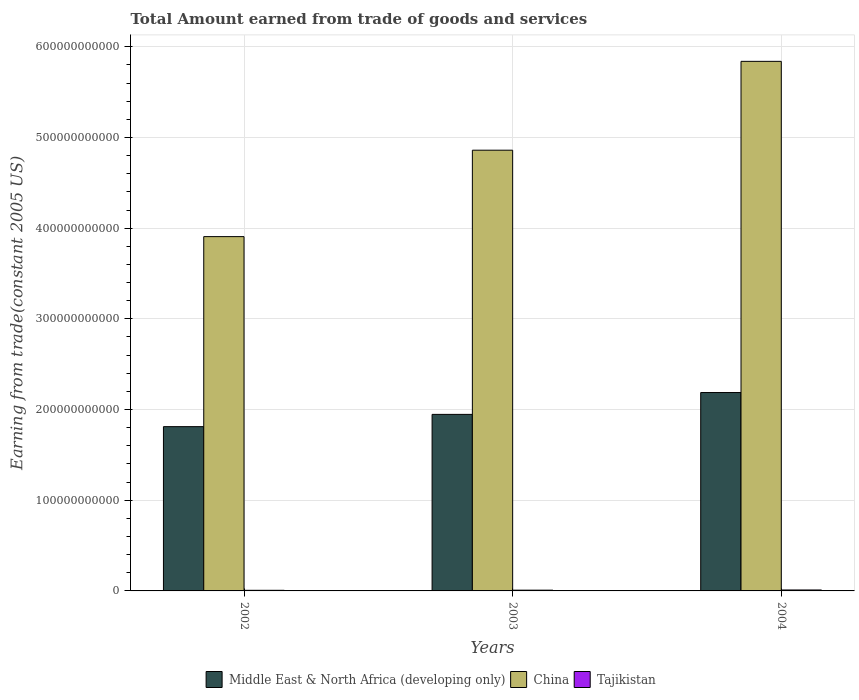How many different coloured bars are there?
Offer a very short reply. 3. Are the number of bars on each tick of the X-axis equal?
Your answer should be very brief. Yes. How many bars are there on the 1st tick from the left?
Your response must be concise. 3. How many bars are there on the 3rd tick from the right?
Your answer should be compact. 3. What is the total amount earned by trading goods and services in China in 2004?
Make the answer very short. 5.84e+11. Across all years, what is the maximum total amount earned by trading goods and services in Middle East & North Africa (developing only)?
Ensure brevity in your answer.  2.19e+11. Across all years, what is the minimum total amount earned by trading goods and services in Middle East & North Africa (developing only)?
Offer a terse response. 1.81e+11. In which year was the total amount earned by trading goods and services in China maximum?
Your answer should be compact. 2004. In which year was the total amount earned by trading goods and services in Middle East & North Africa (developing only) minimum?
Offer a very short reply. 2002. What is the total total amount earned by trading goods and services in Middle East & North Africa (developing only) in the graph?
Give a very brief answer. 5.95e+11. What is the difference between the total amount earned by trading goods and services in Middle East & North Africa (developing only) in 2002 and that in 2004?
Your answer should be compact. -3.76e+1. What is the difference between the total amount earned by trading goods and services in China in 2002 and the total amount earned by trading goods and services in Tajikistan in 2004?
Keep it short and to the point. 3.90e+11. What is the average total amount earned by trading goods and services in Tajikistan per year?
Your answer should be very brief. 8.51e+08. In the year 2002, what is the difference between the total amount earned by trading goods and services in Middle East & North Africa (developing only) and total amount earned by trading goods and services in Tajikistan?
Ensure brevity in your answer.  1.80e+11. What is the ratio of the total amount earned by trading goods and services in Tajikistan in 2002 to that in 2003?
Your response must be concise. 0.81. Is the total amount earned by trading goods and services in Middle East & North Africa (developing only) in 2002 less than that in 2003?
Keep it short and to the point. Yes. What is the difference between the highest and the second highest total amount earned by trading goods and services in Tajikistan?
Offer a terse response. 2.16e+08. What is the difference between the highest and the lowest total amount earned by trading goods and services in China?
Your answer should be very brief. 1.93e+11. In how many years, is the total amount earned by trading goods and services in Middle East & North Africa (developing only) greater than the average total amount earned by trading goods and services in Middle East & North Africa (developing only) taken over all years?
Provide a short and direct response. 1. What does the 2nd bar from the left in 2002 represents?
Offer a terse response. China. What does the 3rd bar from the right in 2003 represents?
Provide a succinct answer. Middle East & North Africa (developing only). What is the difference between two consecutive major ticks on the Y-axis?
Your answer should be compact. 1.00e+11. Are the values on the major ticks of Y-axis written in scientific E-notation?
Your answer should be compact. No. How are the legend labels stacked?
Offer a very short reply. Horizontal. What is the title of the graph?
Offer a terse response. Total Amount earned from trade of goods and services. Does "Pakistan" appear as one of the legend labels in the graph?
Your response must be concise. No. What is the label or title of the X-axis?
Your answer should be very brief. Years. What is the label or title of the Y-axis?
Your answer should be very brief. Earning from trade(constant 2005 US). What is the Earning from trade(constant 2005 US) of Middle East & North Africa (developing only) in 2002?
Make the answer very short. 1.81e+11. What is the Earning from trade(constant 2005 US) in China in 2002?
Your answer should be compact. 3.91e+11. What is the Earning from trade(constant 2005 US) in Tajikistan in 2002?
Provide a short and direct response. 6.73e+08. What is the Earning from trade(constant 2005 US) of Middle East & North Africa (developing only) in 2003?
Offer a terse response. 1.95e+11. What is the Earning from trade(constant 2005 US) of China in 2003?
Provide a short and direct response. 4.86e+11. What is the Earning from trade(constant 2005 US) in Tajikistan in 2003?
Give a very brief answer. 8.32e+08. What is the Earning from trade(constant 2005 US) of Middle East & North Africa (developing only) in 2004?
Provide a short and direct response. 2.19e+11. What is the Earning from trade(constant 2005 US) of China in 2004?
Your answer should be compact. 5.84e+11. What is the Earning from trade(constant 2005 US) of Tajikistan in 2004?
Keep it short and to the point. 1.05e+09. Across all years, what is the maximum Earning from trade(constant 2005 US) in Middle East & North Africa (developing only)?
Make the answer very short. 2.19e+11. Across all years, what is the maximum Earning from trade(constant 2005 US) in China?
Ensure brevity in your answer.  5.84e+11. Across all years, what is the maximum Earning from trade(constant 2005 US) in Tajikistan?
Give a very brief answer. 1.05e+09. Across all years, what is the minimum Earning from trade(constant 2005 US) of Middle East & North Africa (developing only)?
Provide a short and direct response. 1.81e+11. Across all years, what is the minimum Earning from trade(constant 2005 US) in China?
Make the answer very short. 3.91e+11. Across all years, what is the minimum Earning from trade(constant 2005 US) of Tajikistan?
Offer a terse response. 6.73e+08. What is the total Earning from trade(constant 2005 US) in Middle East & North Africa (developing only) in the graph?
Offer a terse response. 5.95e+11. What is the total Earning from trade(constant 2005 US) in China in the graph?
Keep it short and to the point. 1.46e+12. What is the total Earning from trade(constant 2005 US) of Tajikistan in the graph?
Keep it short and to the point. 2.55e+09. What is the difference between the Earning from trade(constant 2005 US) of Middle East & North Africa (developing only) in 2002 and that in 2003?
Offer a very short reply. -1.35e+1. What is the difference between the Earning from trade(constant 2005 US) of China in 2002 and that in 2003?
Keep it short and to the point. -9.53e+1. What is the difference between the Earning from trade(constant 2005 US) of Tajikistan in 2002 and that in 2003?
Provide a succinct answer. -1.59e+08. What is the difference between the Earning from trade(constant 2005 US) in Middle East & North Africa (developing only) in 2002 and that in 2004?
Offer a very short reply. -3.76e+1. What is the difference between the Earning from trade(constant 2005 US) of China in 2002 and that in 2004?
Make the answer very short. -1.93e+11. What is the difference between the Earning from trade(constant 2005 US) in Tajikistan in 2002 and that in 2004?
Offer a terse response. -3.75e+08. What is the difference between the Earning from trade(constant 2005 US) in Middle East & North Africa (developing only) in 2003 and that in 2004?
Provide a short and direct response. -2.41e+1. What is the difference between the Earning from trade(constant 2005 US) of China in 2003 and that in 2004?
Offer a terse response. -9.80e+1. What is the difference between the Earning from trade(constant 2005 US) of Tajikistan in 2003 and that in 2004?
Give a very brief answer. -2.16e+08. What is the difference between the Earning from trade(constant 2005 US) of Middle East & North Africa (developing only) in 2002 and the Earning from trade(constant 2005 US) of China in 2003?
Your answer should be very brief. -3.05e+11. What is the difference between the Earning from trade(constant 2005 US) of Middle East & North Africa (developing only) in 2002 and the Earning from trade(constant 2005 US) of Tajikistan in 2003?
Your answer should be compact. 1.80e+11. What is the difference between the Earning from trade(constant 2005 US) in China in 2002 and the Earning from trade(constant 2005 US) in Tajikistan in 2003?
Provide a succinct answer. 3.90e+11. What is the difference between the Earning from trade(constant 2005 US) in Middle East & North Africa (developing only) in 2002 and the Earning from trade(constant 2005 US) in China in 2004?
Keep it short and to the point. -4.03e+11. What is the difference between the Earning from trade(constant 2005 US) of Middle East & North Africa (developing only) in 2002 and the Earning from trade(constant 2005 US) of Tajikistan in 2004?
Give a very brief answer. 1.80e+11. What is the difference between the Earning from trade(constant 2005 US) in China in 2002 and the Earning from trade(constant 2005 US) in Tajikistan in 2004?
Ensure brevity in your answer.  3.90e+11. What is the difference between the Earning from trade(constant 2005 US) in Middle East & North Africa (developing only) in 2003 and the Earning from trade(constant 2005 US) in China in 2004?
Your answer should be compact. -3.89e+11. What is the difference between the Earning from trade(constant 2005 US) of Middle East & North Africa (developing only) in 2003 and the Earning from trade(constant 2005 US) of Tajikistan in 2004?
Offer a terse response. 1.94e+11. What is the difference between the Earning from trade(constant 2005 US) of China in 2003 and the Earning from trade(constant 2005 US) of Tajikistan in 2004?
Your response must be concise. 4.85e+11. What is the average Earning from trade(constant 2005 US) of Middle East & North Africa (developing only) per year?
Your answer should be compact. 1.98e+11. What is the average Earning from trade(constant 2005 US) in China per year?
Offer a very short reply. 4.87e+11. What is the average Earning from trade(constant 2005 US) of Tajikistan per year?
Offer a terse response. 8.51e+08. In the year 2002, what is the difference between the Earning from trade(constant 2005 US) in Middle East & North Africa (developing only) and Earning from trade(constant 2005 US) in China?
Your answer should be compact. -2.10e+11. In the year 2002, what is the difference between the Earning from trade(constant 2005 US) in Middle East & North Africa (developing only) and Earning from trade(constant 2005 US) in Tajikistan?
Offer a terse response. 1.80e+11. In the year 2002, what is the difference between the Earning from trade(constant 2005 US) in China and Earning from trade(constant 2005 US) in Tajikistan?
Provide a succinct answer. 3.90e+11. In the year 2003, what is the difference between the Earning from trade(constant 2005 US) in Middle East & North Africa (developing only) and Earning from trade(constant 2005 US) in China?
Your answer should be very brief. -2.91e+11. In the year 2003, what is the difference between the Earning from trade(constant 2005 US) of Middle East & North Africa (developing only) and Earning from trade(constant 2005 US) of Tajikistan?
Your answer should be compact. 1.94e+11. In the year 2003, what is the difference between the Earning from trade(constant 2005 US) of China and Earning from trade(constant 2005 US) of Tajikistan?
Provide a succinct answer. 4.85e+11. In the year 2004, what is the difference between the Earning from trade(constant 2005 US) in Middle East & North Africa (developing only) and Earning from trade(constant 2005 US) in China?
Ensure brevity in your answer.  -3.65e+11. In the year 2004, what is the difference between the Earning from trade(constant 2005 US) of Middle East & North Africa (developing only) and Earning from trade(constant 2005 US) of Tajikistan?
Provide a succinct answer. 2.18e+11. In the year 2004, what is the difference between the Earning from trade(constant 2005 US) of China and Earning from trade(constant 2005 US) of Tajikistan?
Your answer should be compact. 5.83e+11. What is the ratio of the Earning from trade(constant 2005 US) in Middle East & North Africa (developing only) in 2002 to that in 2003?
Your response must be concise. 0.93. What is the ratio of the Earning from trade(constant 2005 US) of China in 2002 to that in 2003?
Make the answer very short. 0.8. What is the ratio of the Earning from trade(constant 2005 US) in Tajikistan in 2002 to that in 2003?
Keep it short and to the point. 0.81. What is the ratio of the Earning from trade(constant 2005 US) in Middle East & North Africa (developing only) in 2002 to that in 2004?
Ensure brevity in your answer.  0.83. What is the ratio of the Earning from trade(constant 2005 US) in China in 2002 to that in 2004?
Provide a succinct answer. 0.67. What is the ratio of the Earning from trade(constant 2005 US) in Tajikistan in 2002 to that in 2004?
Make the answer very short. 0.64. What is the ratio of the Earning from trade(constant 2005 US) in Middle East & North Africa (developing only) in 2003 to that in 2004?
Your answer should be very brief. 0.89. What is the ratio of the Earning from trade(constant 2005 US) of China in 2003 to that in 2004?
Your answer should be compact. 0.83. What is the ratio of the Earning from trade(constant 2005 US) of Tajikistan in 2003 to that in 2004?
Your response must be concise. 0.79. What is the difference between the highest and the second highest Earning from trade(constant 2005 US) of Middle East & North Africa (developing only)?
Provide a succinct answer. 2.41e+1. What is the difference between the highest and the second highest Earning from trade(constant 2005 US) in China?
Your response must be concise. 9.80e+1. What is the difference between the highest and the second highest Earning from trade(constant 2005 US) in Tajikistan?
Your answer should be compact. 2.16e+08. What is the difference between the highest and the lowest Earning from trade(constant 2005 US) of Middle East & North Africa (developing only)?
Make the answer very short. 3.76e+1. What is the difference between the highest and the lowest Earning from trade(constant 2005 US) of China?
Make the answer very short. 1.93e+11. What is the difference between the highest and the lowest Earning from trade(constant 2005 US) in Tajikistan?
Your answer should be very brief. 3.75e+08. 